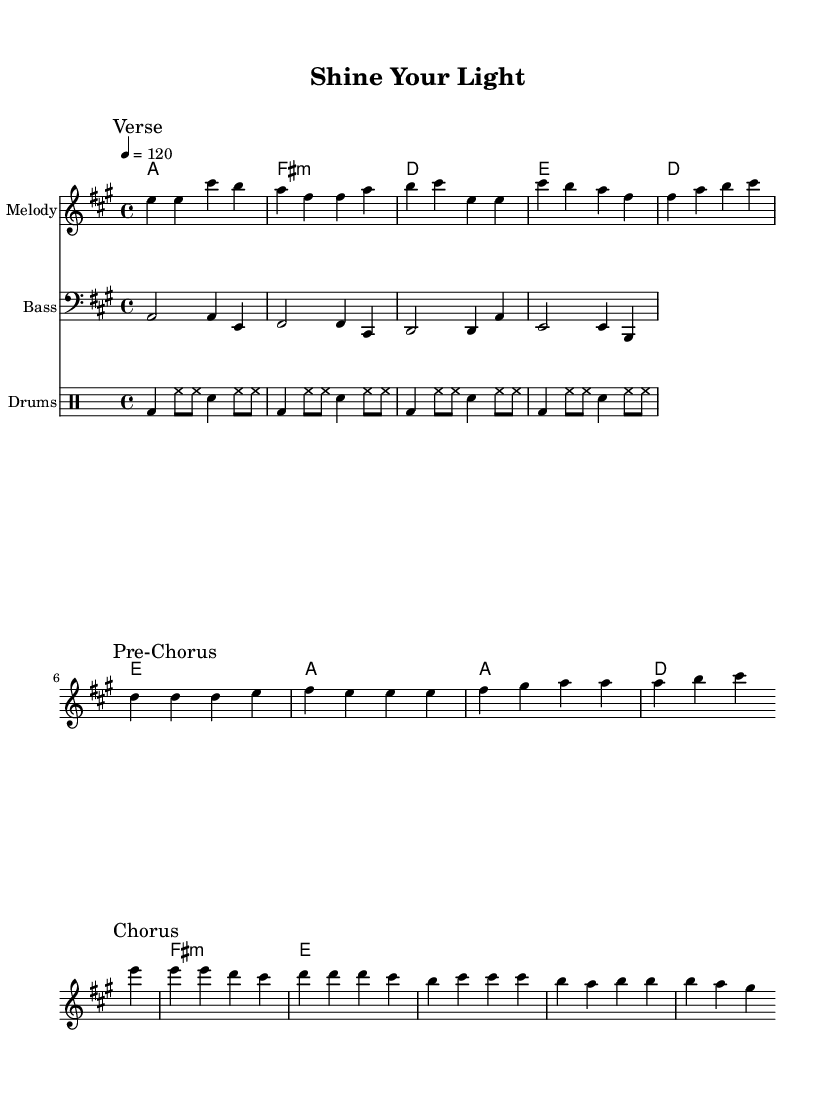What is the key signature of this music? The key signature is indicated by the number of sharps or flats in the piece. Here, there are three sharps (F#, C#, and G#) which corresponds to the key of A major.
Answer: A major What is the time signature of this piece? The time signature is shown at the beginning of the score. Here, it is represented as 4/4, which means there are four beats in each measure and the quarter note gets one beat.
Answer: 4/4 What is the tempo marking for this music? The tempo marking is indicated by the numbers and description following "tempo". In this case, 4 = 120 means the piece should be played at a speed of 120 beats per minute.
Answer: 120 How many measures are in the chorus section? By analyzing the score, the chorus section appears after the pre-chorus and consists of four measures that involve specific note patterns that define this part.
Answer: 4 What is the first note of the melody? To find the first note of the melody, we look at the top staff under "Melody." The first note in the melody is E, which is indicated right at the beginning of the musical score.
Answer: E Which chord type is used in the second harmony? The second harmony listed shows "fis:m," which specifies that the chord is an F# minor chord, indicated by the "m" following the root note.
Answer: F# minor What rhythmic pattern is used in the drum part? The drum part consists of a repeating pattern shown through the notational symbols for bass drum, hi-hat, and snare drum. The pattern is characterized by a mix of quarter and eighth notes throughout the section.
Answer: Bass and hi-hat 